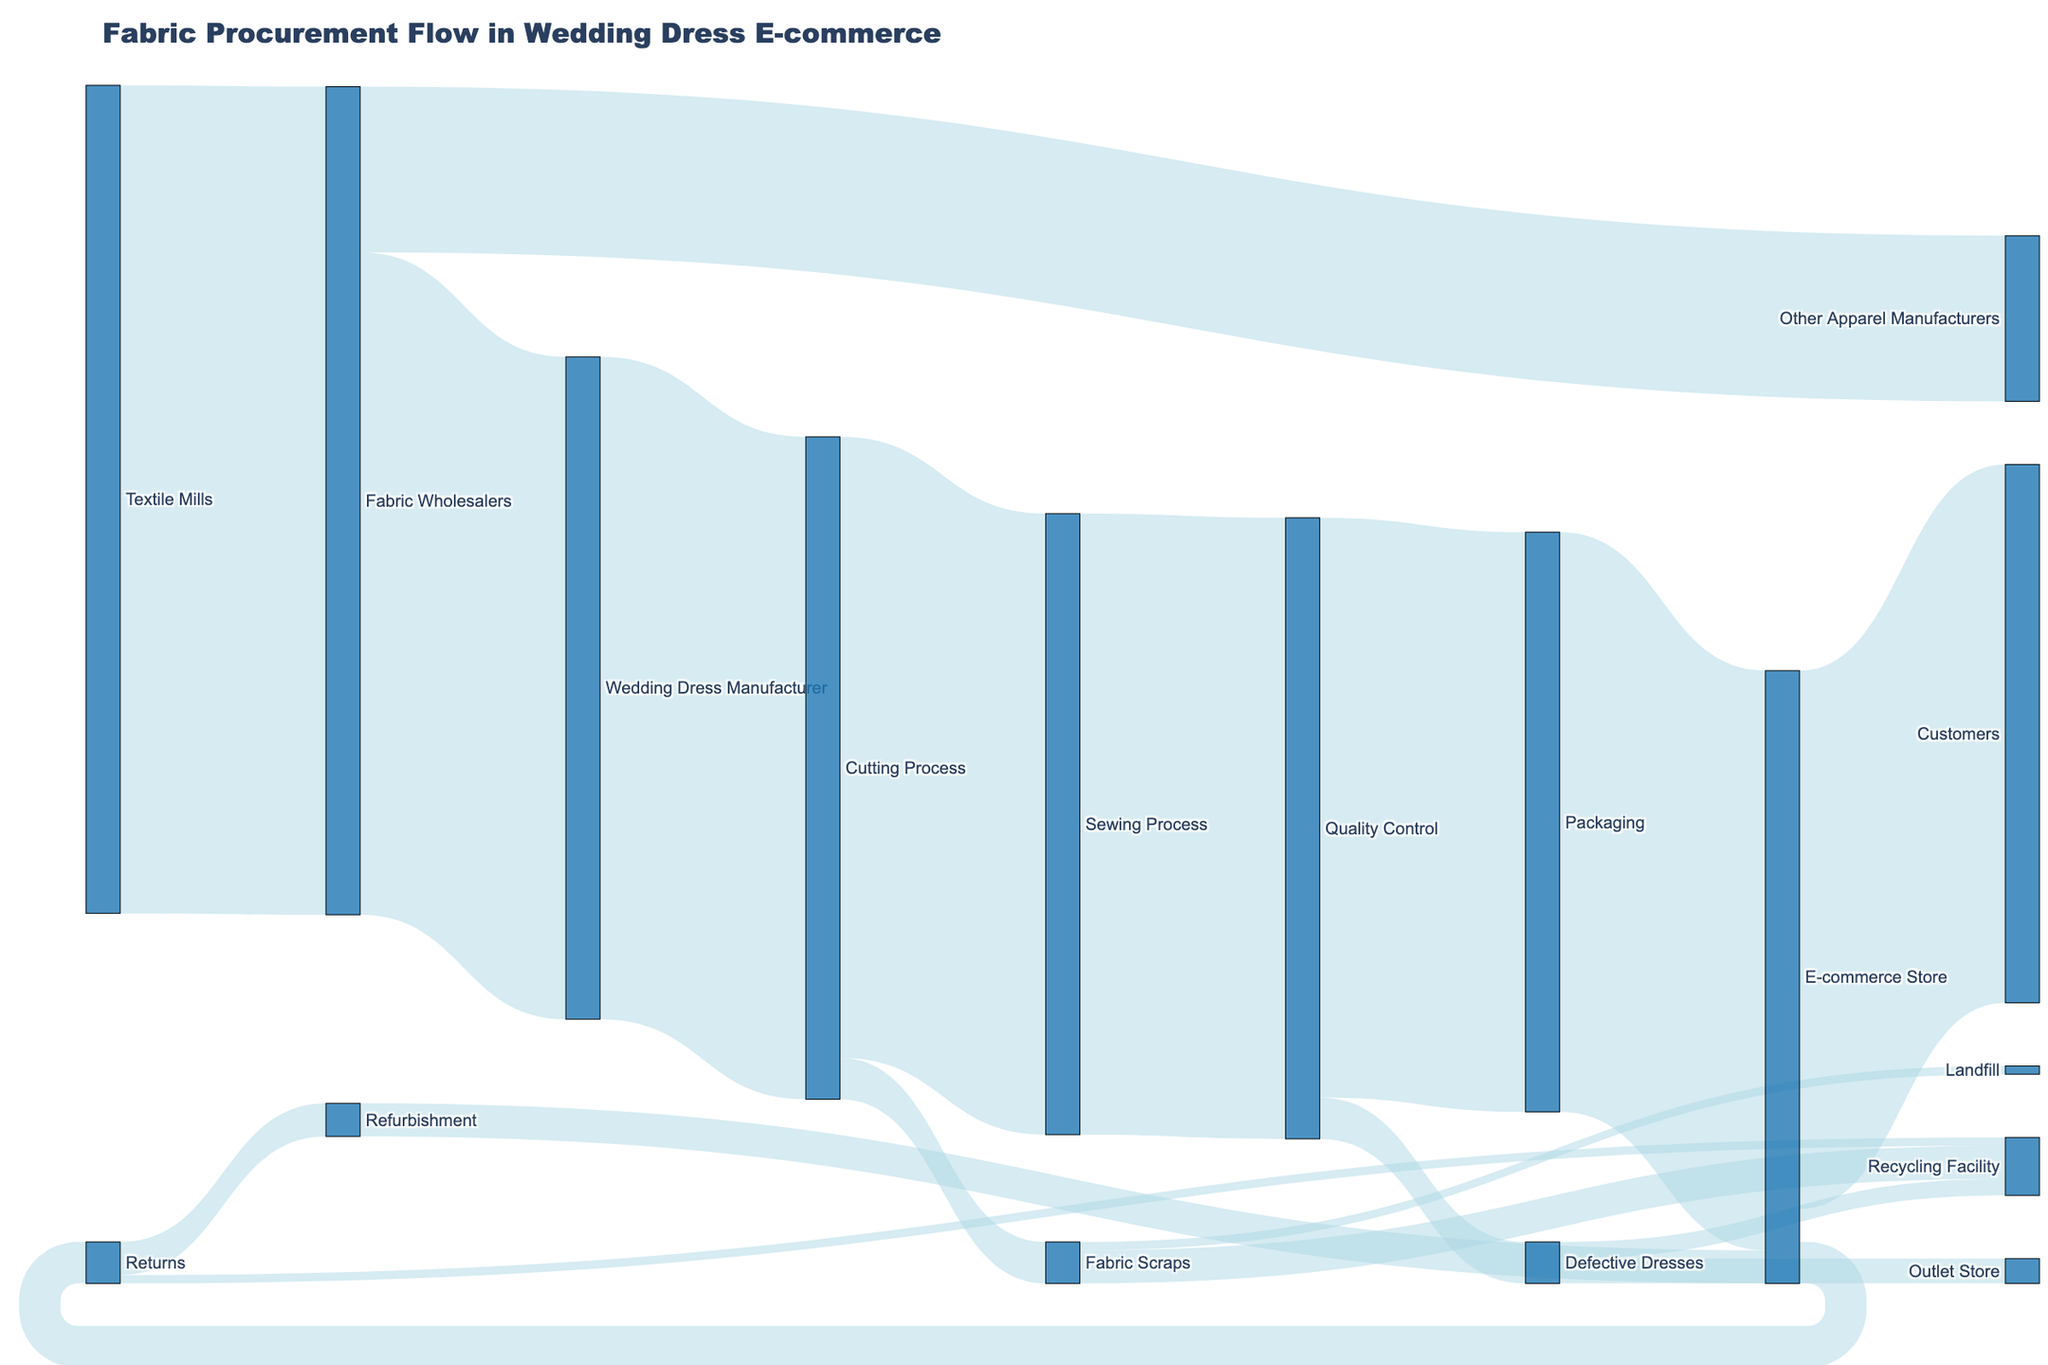What is the total amount of fabric received by Fabric Wholesalers from Textile Mills? This is directly visible in the diagram where Fabric Wholesalers receive 1000 units from Textile Mills.
Answer: 1000 How much fabric is sent to wedding dress manufacturers from Fabric Wholesalers? By referring to the flow from Fabric Wholesalers to Wedding Dress Manufacturer, we see that 800 units are sent.
Answer: 800 What is the total amount of fabric that ends up being waste or recycled after the Cutting Process? Fabric Scraps from the Cutting Process are 50 units, which is split into Recycling Facility (40) and Landfill (10). Thus, the total waste/recycling is calculated by summing these values.
Answer: 50 How many units of fabric are wasted during the Quality Control process? The flow of fabric that becomes Defective Dresses in the Quality Control stage is directly shown as 50 units.
Answer: 50 Which stage receives the highest amount of fabric after the Cutting Process? The Sankey diagram shows two major flows from Cutting Process: Sewing Process (750 units) and Fabric Scraps (50 units). The Sewing Process receives more fabric.
Answer: Sewing Process What is the total number of dresses that reach the Outlet Store? The flow of defective dresses from Quality Control to Outlet Store is 30 units.
Answer: 30 How many units are ultimately received by customers from the e-commerce store? The flow from E-commerce Store to Customers is 650 units.
Answer: 650 Compare the amount of fabric that ends up in the Landfill versus the Recycling Facility from Fabric Scraps. The Sankey diagram illustrates that 10 units go to Landfill and 40 units to Recycling Facility. Comparing these shows that more fabric scraps are recycled.
Answer: Recycling Facility What percentage of the initial fabric received by Fabric Wholesalers ends up in the e-commerce store? The initial fabric received by Fabric Wholesalers is 1000 units. The total fabric reaching the E-commerce Store from the Packaging stage is 700 units. The calculation is (700/1000) x 100 = 70%.
Answer: 70% How many units are returned by customers? The Sankey diagram indicates that 50 units are returned from the E-commerce store.
Answer: 50 